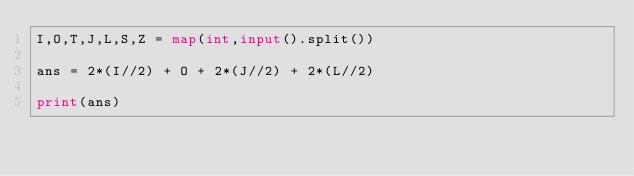<code> <loc_0><loc_0><loc_500><loc_500><_Python_>I,O,T,J,L,S,Z = map(int,input().split())

ans = 2*(I//2) + O + 2*(J//2) + 2*(L//2)

print(ans)
</code> 